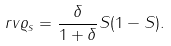Convert formula to latex. <formula><loc_0><loc_0><loc_500><loc_500>\ r v { \varrho } _ { s } = \frac { \delta } { 1 + \delta } S ( 1 - S ) .</formula> 